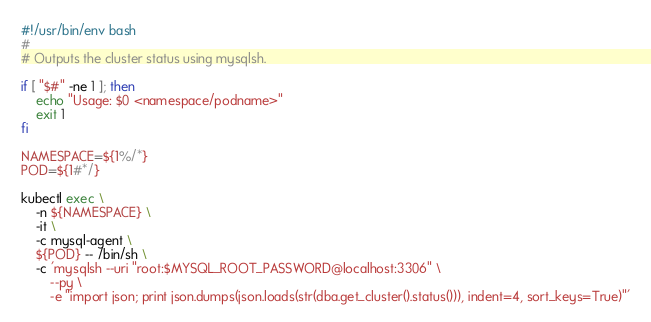Convert code to text. <code><loc_0><loc_0><loc_500><loc_500><_Bash_>#!/usr/bin/env bash
#
# Outputs the cluster status using mysqlsh.

if [ "$#" -ne 1 ]; then
    echo "Usage: $0 <namespace/podname>"
    exit 1
fi

NAMESPACE=${1%/*}
POD=${1#*/}

kubectl exec \
    -n ${NAMESPACE} \
    -it \
    -c mysql-agent \
    ${POD} -- /bin/sh \
    -c 'mysqlsh --uri "root:$MYSQL_ROOT_PASSWORD@localhost:3306" \
        --py \
        -e "import json; print json.dumps(json.loads(str(dba.get_cluster().status())), indent=4, sort_keys=True)"'
</code> 